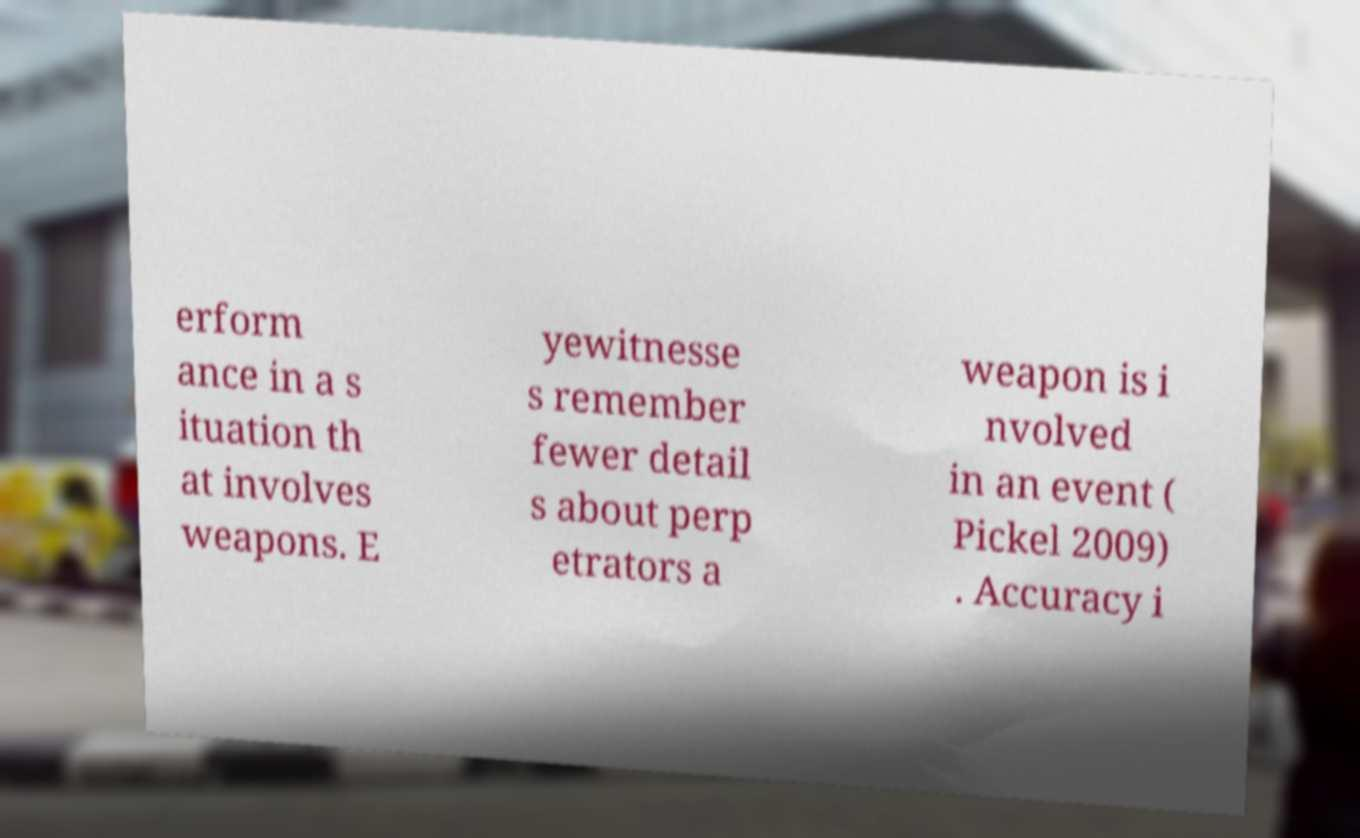What messages or text are displayed in this image? I need them in a readable, typed format. erform ance in a s ituation th at involves weapons. E yewitnesse s remember fewer detail s about perp etrators a weapon is i nvolved in an event ( Pickel 2009) . Accuracy i 